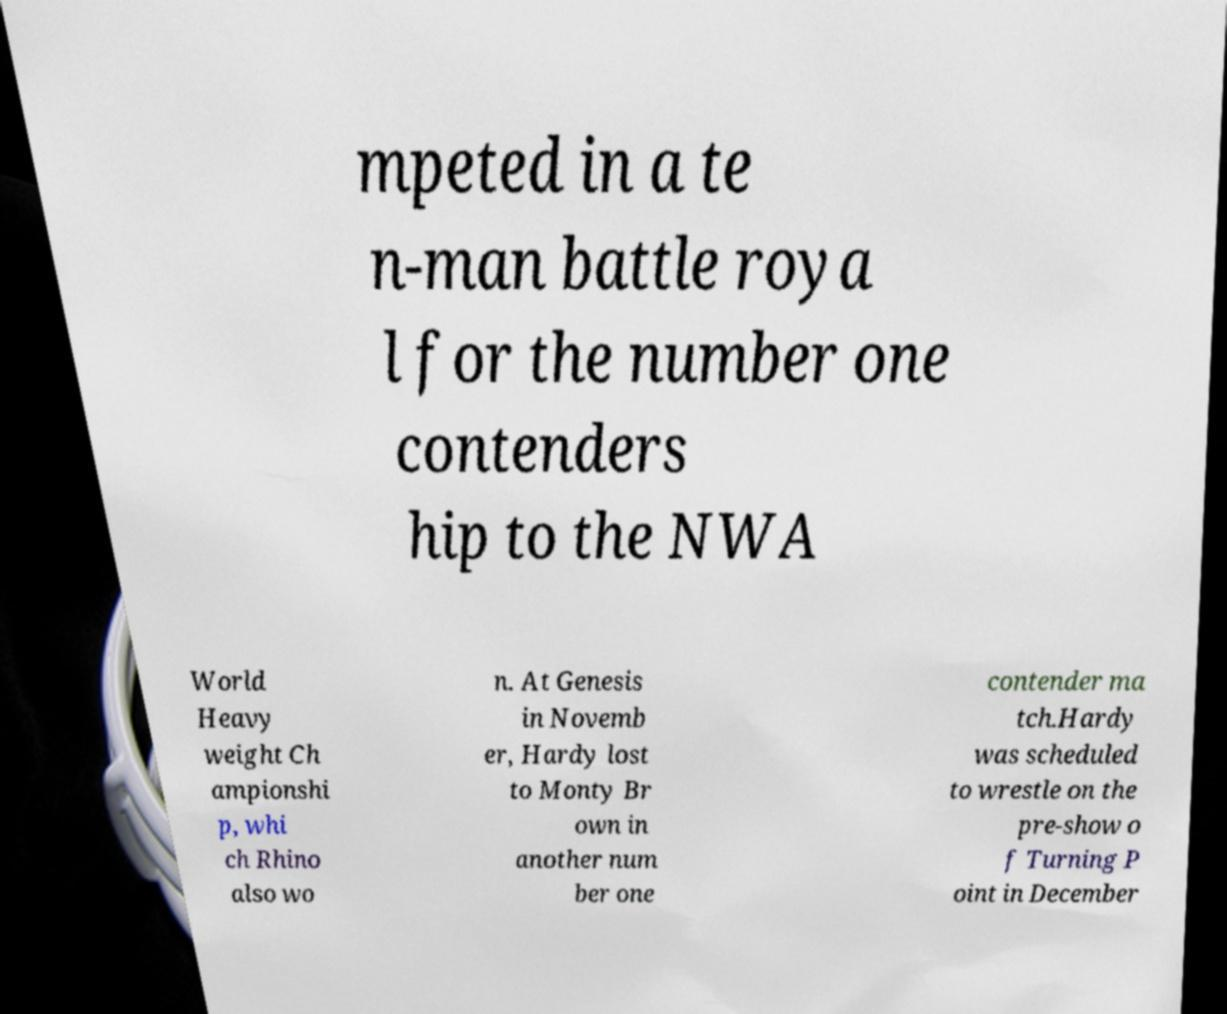There's text embedded in this image that I need extracted. Can you transcribe it verbatim? mpeted in a te n-man battle roya l for the number one contenders hip to the NWA World Heavy weight Ch ampionshi p, whi ch Rhino also wo n. At Genesis in Novemb er, Hardy lost to Monty Br own in another num ber one contender ma tch.Hardy was scheduled to wrestle on the pre-show o f Turning P oint in December 